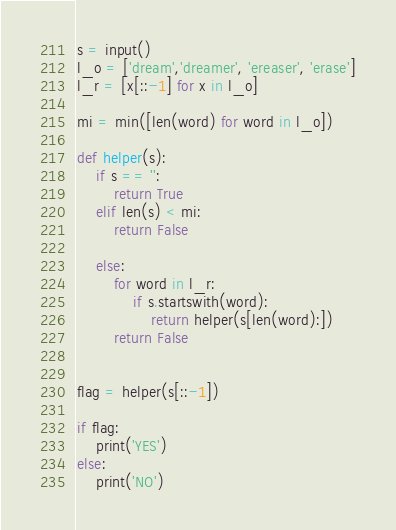Convert code to text. <code><loc_0><loc_0><loc_500><loc_500><_Python_>s = input()
l_o = ['dream','dreamer', 'ereaser', 'erase']
l_r = [x[::-1] for x in l_o]

mi = min([len(word) for word in l_o])

def helper(s):
    if s == '':
        return True
    elif len(s) < mi:
        return False

    else:
        for word in l_r:
            if s.startswith(word):
                return helper(s[len(word):])
        return False


flag = helper(s[::-1])

if flag:
    print('YES')
else:
    print('NO')
</code> 